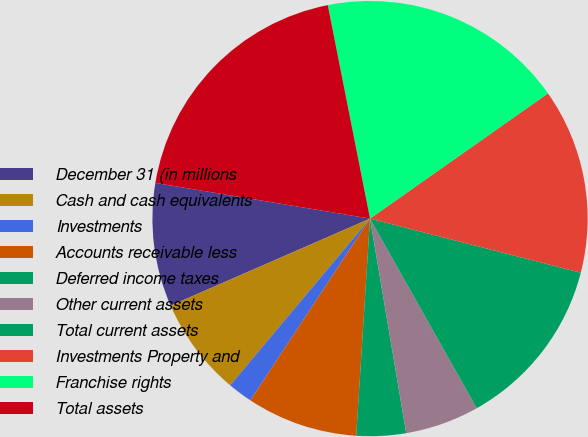<chart> <loc_0><loc_0><loc_500><loc_500><pie_chart><fcel>December 31 (in millions<fcel>Cash and cash equivalents<fcel>Investments<fcel>Accounts receivable less<fcel>Deferred income taxes<fcel>Other current assets<fcel>Total current assets<fcel>Investments Property and<fcel>Franchise rights<fcel>Total assets<nl><fcel>9.17%<fcel>7.34%<fcel>1.84%<fcel>8.26%<fcel>3.67%<fcel>5.5%<fcel>12.84%<fcel>13.76%<fcel>18.35%<fcel>19.27%<nl></chart> 